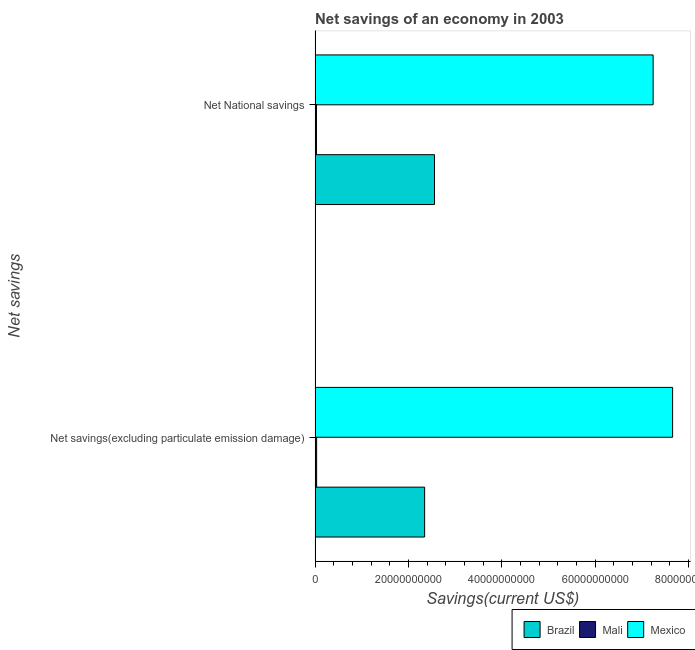Are the number of bars per tick equal to the number of legend labels?
Provide a short and direct response. Yes. Are the number of bars on each tick of the Y-axis equal?
Ensure brevity in your answer.  Yes. What is the label of the 2nd group of bars from the top?
Provide a succinct answer. Net savings(excluding particulate emission damage). What is the net savings(excluding particulate emission damage) in Mexico?
Your answer should be very brief. 7.66e+1. Across all countries, what is the maximum net national savings?
Make the answer very short. 7.24e+1. Across all countries, what is the minimum net national savings?
Make the answer very short. 2.93e+08. In which country was the net national savings minimum?
Offer a terse response. Mali. What is the total net national savings in the graph?
Offer a terse response. 9.83e+1. What is the difference between the net savings(excluding particulate emission damage) in Mali and that in Brazil?
Your answer should be compact. -2.31e+1. What is the difference between the net national savings in Mali and the net savings(excluding particulate emission damage) in Mexico?
Your answer should be compact. -7.63e+1. What is the average net savings(excluding particulate emission damage) per country?
Your answer should be very brief. 3.35e+1. What is the difference between the net national savings and net savings(excluding particulate emission damage) in Mexico?
Make the answer very short. -4.18e+09. In how many countries, is the net national savings greater than 72000000000 US$?
Give a very brief answer. 1. What is the ratio of the net national savings in Mexico to that in Brazil?
Give a very brief answer. 2.83. Is the net national savings in Brazil less than that in Mexico?
Provide a short and direct response. Yes. What does the 2nd bar from the top in Net savings(excluding particulate emission damage) represents?
Make the answer very short. Mali. What does the 2nd bar from the bottom in Net National savings represents?
Ensure brevity in your answer.  Mali. How many bars are there?
Provide a short and direct response. 6. Are all the bars in the graph horizontal?
Ensure brevity in your answer.  Yes. What is the difference between two consecutive major ticks on the X-axis?
Your answer should be compact. 2.00e+1. Are the values on the major ticks of X-axis written in scientific E-notation?
Give a very brief answer. No. Does the graph contain grids?
Offer a very short reply. No. How are the legend labels stacked?
Provide a succinct answer. Horizontal. What is the title of the graph?
Your answer should be compact. Net savings of an economy in 2003. What is the label or title of the X-axis?
Offer a very short reply. Savings(current US$). What is the label or title of the Y-axis?
Provide a short and direct response. Net savings. What is the Savings(current US$) in Brazil in Net savings(excluding particulate emission damage)?
Offer a very short reply. 2.35e+1. What is the Savings(current US$) of Mali in Net savings(excluding particulate emission damage)?
Your answer should be very brief. 3.28e+08. What is the Savings(current US$) in Mexico in Net savings(excluding particulate emission damage)?
Ensure brevity in your answer.  7.66e+1. What is the Savings(current US$) in Brazil in Net National savings?
Offer a very short reply. 2.56e+1. What is the Savings(current US$) of Mali in Net National savings?
Offer a very short reply. 2.93e+08. What is the Savings(current US$) in Mexico in Net National savings?
Provide a short and direct response. 7.24e+1. Across all Net savings, what is the maximum Savings(current US$) of Brazil?
Offer a very short reply. 2.56e+1. Across all Net savings, what is the maximum Savings(current US$) of Mali?
Your answer should be very brief. 3.28e+08. Across all Net savings, what is the maximum Savings(current US$) in Mexico?
Give a very brief answer. 7.66e+1. Across all Net savings, what is the minimum Savings(current US$) of Brazil?
Your answer should be very brief. 2.35e+1. Across all Net savings, what is the minimum Savings(current US$) of Mali?
Offer a terse response. 2.93e+08. Across all Net savings, what is the minimum Savings(current US$) in Mexico?
Your answer should be compact. 7.24e+1. What is the total Savings(current US$) in Brazil in the graph?
Keep it short and to the point. 4.91e+1. What is the total Savings(current US$) in Mali in the graph?
Offer a very short reply. 6.21e+08. What is the total Savings(current US$) of Mexico in the graph?
Your answer should be compact. 1.49e+11. What is the difference between the Savings(current US$) in Brazil in Net savings(excluding particulate emission damage) and that in Net National savings?
Make the answer very short. -2.12e+09. What is the difference between the Savings(current US$) in Mali in Net savings(excluding particulate emission damage) and that in Net National savings?
Your answer should be compact. 3.47e+07. What is the difference between the Savings(current US$) in Mexico in Net savings(excluding particulate emission damage) and that in Net National savings?
Offer a terse response. 4.18e+09. What is the difference between the Savings(current US$) in Brazil in Net savings(excluding particulate emission damage) and the Savings(current US$) in Mali in Net National savings?
Provide a short and direct response. 2.32e+1. What is the difference between the Savings(current US$) of Brazil in Net savings(excluding particulate emission damage) and the Savings(current US$) of Mexico in Net National savings?
Offer a very short reply. -4.90e+1. What is the difference between the Savings(current US$) in Mali in Net savings(excluding particulate emission damage) and the Savings(current US$) in Mexico in Net National savings?
Your answer should be very brief. -7.21e+1. What is the average Savings(current US$) of Brazil per Net savings?
Offer a terse response. 2.45e+1. What is the average Savings(current US$) in Mali per Net savings?
Ensure brevity in your answer.  3.11e+08. What is the average Savings(current US$) of Mexico per Net savings?
Your answer should be very brief. 7.45e+1. What is the difference between the Savings(current US$) in Brazil and Savings(current US$) in Mali in Net savings(excluding particulate emission damage)?
Give a very brief answer. 2.31e+1. What is the difference between the Savings(current US$) in Brazil and Savings(current US$) in Mexico in Net savings(excluding particulate emission damage)?
Give a very brief answer. -5.31e+1. What is the difference between the Savings(current US$) in Mali and Savings(current US$) in Mexico in Net savings(excluding particulate emission damage)?
Make the answer very short. -7.63e+1. What is the difference between the Savings(current US$) of Brazil and Savings(current US$) of Mali in Net National savings?
Make the answer very short. 2.53e+1. What is the difference between the Savings(current US$) in Brazil and Savings(current US$) in Mexico in Net National savings?
Give a very brief answer. -4.69e+1. What is the difference between the Savings(current US$) in Mali and Savings(current US$) in Mexico in Net National savings?
Keep it short and to the point. -7.21e+1. What is the ratio of the Savings(current US$) of Brazil in Net savings(excluding particulate emission damage) to that in Net National savings?
Your answer should be very brief. 0.92. What is the ratio of the Savings(current US$) in Mali in Net savings(excluding particulate emission damage) to that in Net National savings?
Your answer should be very brief. 1.12. What is the ratio of the Savings(current US$) in Mexico in Net savings(excluding particulate emission damage) to that in Net National savings?
Ensure brevity in your answer.  1.06. What is the difference between the highest and the second highest Savings(current US$) in Brazil?
Your response must be concise. 2.12e+09. What is the difference between the highest and the second highest Savings(current US$) of Mali?
Your answer should be very brief. 3.47e+07. What is the difference between the highest and the second highest Savings(current US$) in Mexico?
Keep it short and to the point. 4.18e+09. What is the difference between the highest and the lowest Savings(current US$) in Brazil?
Provide a short and direct response. 2.12e+09. What is the difference between the highest and the lowest Savings(current US$) in Mali?
Offer a very short reply. 3.47e+07. What is the difference between the highest and the lowest Savings(current US$) of Mexico?
Provide a short and direct response. 4.18e+09. 